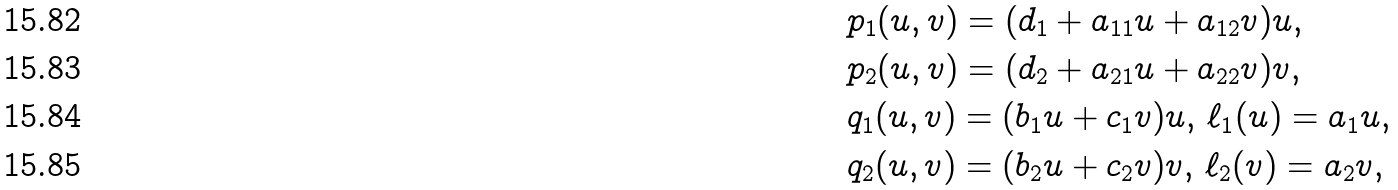Convert formula to latex. <formula><loc_0><loc_0><loc_500><loc_500>& p _ { 1 } ( u , v ) = ( d _ { 1 } + a _ { 1 1 } u + a _ { 1 2 } v ) u , \\ & p _ { 2 } ( u , v ) = ( d _ { 2 } + a _ { 2 1 } u + a _ { 2 2 } v ) v , \\ & q _ { 1 } ( u , v ) = ( b _ { 1 } u + c _ { 1 } v ) u , \, \ell _ { 1 } ( u ) = a _ { 1 } u , \\ & q _ { 2 } ( u , v ) = ( b _ { 2 } u + c _ { 2 } v ) v , \, \ell _ { 2 } ( v ) = a _ { 2 } v ,</formula> 